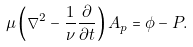<formula> <loc_0><loc_0><loc_500><loc_500>\mu \left ( \nabla ^ { 2 } - \frac { 1 } { \nu } \frac { \partial } { \partial t } \right ) A _ { p } = \phi - P .</formula> 